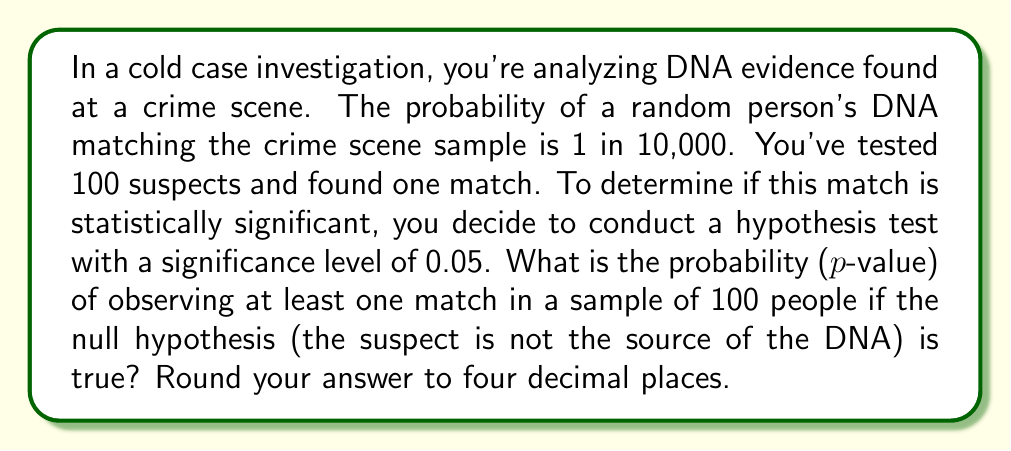Solve this math problem. Let's approach this step-by-step:

1) First, we need to understand what we're calculating. We want to find the probability of at least one match in 100 trials, given that the probability of a match for each trial is 1/10,000.

2) It's easier to calculate the probability of no matches and then subtract from 1:
   P(at least one match) = 1 - P(no matches)

3) The probability of no match for a single trial is:
   $$ P(\text{no match}) = 1 - \frac{1}{10000} = 0.9999 $$

4) For 100 independent trials, the probability of no matches is:
   $$ P(\text{no matches in 100 trials}) = (0.9999)^{100} $$

5) We can calculate this:
   $$ (0.9999)^{100} \approx 0.99004 $$

6) Therefore, the probability of at least one match is:
   $$ P(\text{at least one match}) = 1 - 0.99004 = 0.00996 $$

7) This is our p-value. Rounded to four decimal places, it's 0.0100.

8) Since this p-value (0.0100) is less than our significance level (0.05), we would reject the null hypothesis. This suggests that the DNA match is statistically significant and not likely to have occurred by chance.
Answer: 0.0100 